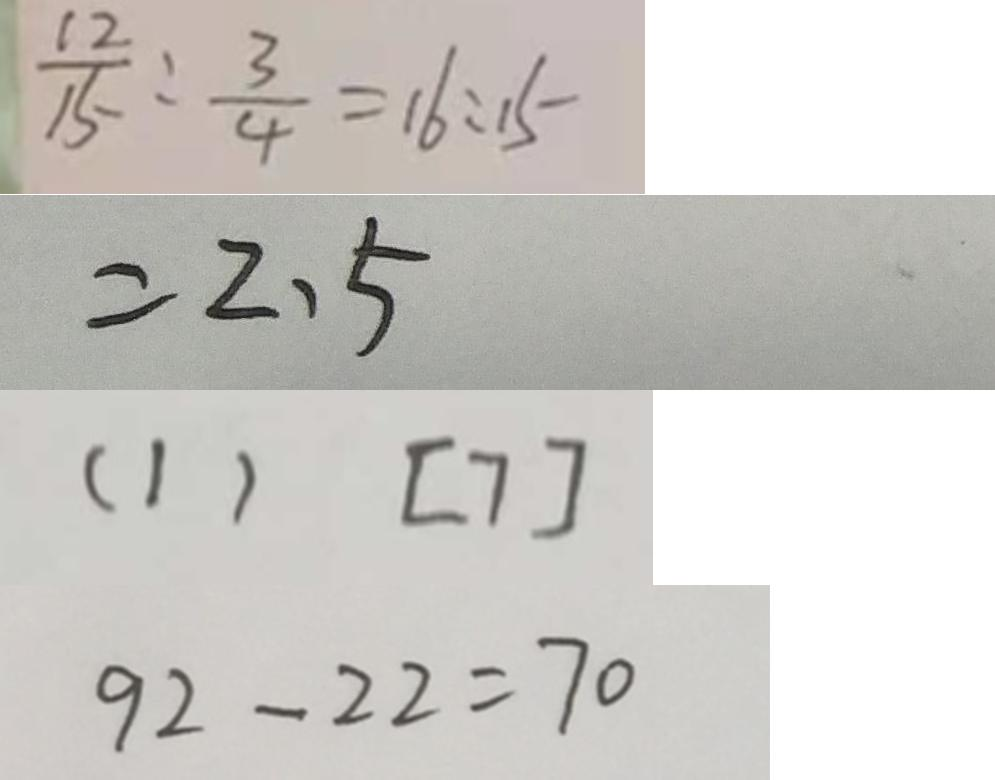<formula> <loc_0><loc_0><loc_500><loc_500>\frac { 1 2 } { 1 5 } : \frac { 3 } { 4 } = 1 6 : 1 5 
 = 2 . 5 
 ( 1 ) [ 7 ] 
 9 2 - 2 2 = 7 0</formula> 